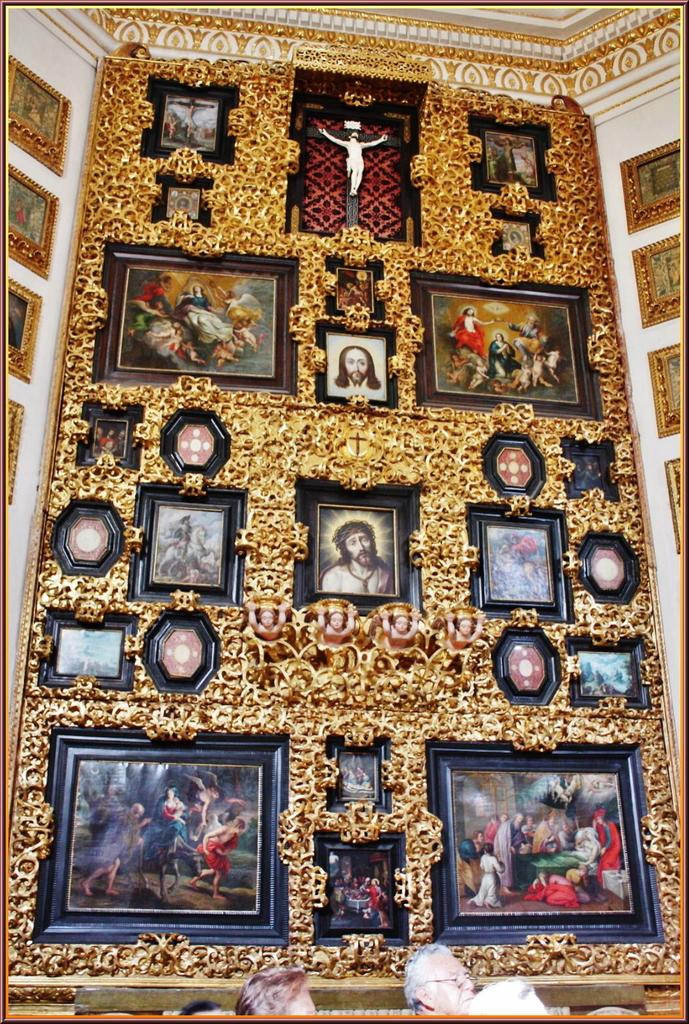What is the main subject of the image? The main subject of the image is a big frame with many photographs. Are there any other frames visible in the image? Yes, there are frames attached to the wall on both the right and left sides of the image. What type of seed is being planted in the frames on the wall? There are no seeds or planting activities depicted in the image; it features frames with photographs. What company is responsible for the design of the frames in the image? The image does not provide information about the company responsible for the design of the frames. 